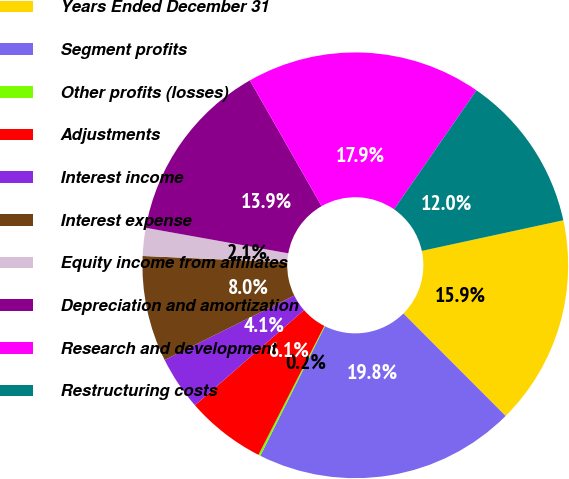Convert chart to OTSL. <chart><loc_0><loc_0><loc_500><loc_500><pie_chart><fcel>Years Ended December 31<fcel>Segment profits<fcel>Other profits (losses)<fcel>Adjustments<fcel>Interest income<fcel>Interest expense<fcel>Equity income from affiliates<fcel>Depreciation and amortization<fcel>Research and development<fcel>Restructuring costs<nl><fcel>15.91%<fcel>19.84%<fcel>0.16%<fcel>6.06%<fcel>4.09%<fcel>8.03%<fcel>2.12%<fcel>13.94%<fcel>17.88%<fcel>11.97%<nl></chart> 